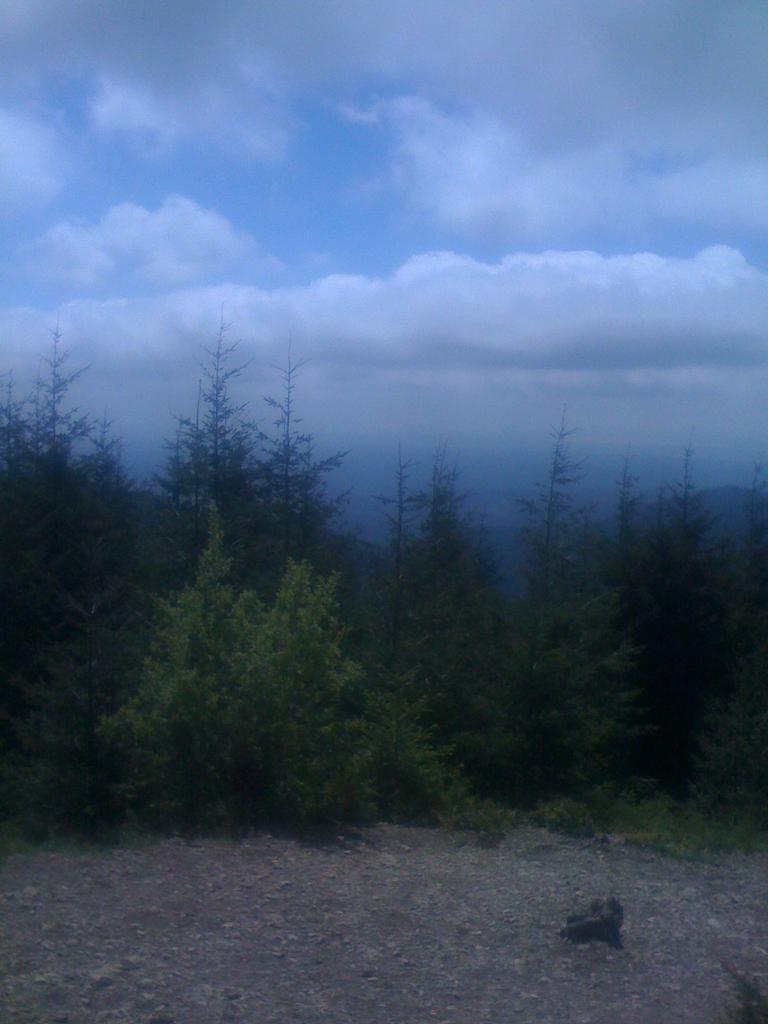Describe this image in one or two sentences. In this image, we can see trees and at the bottom, there is ground and we can see an object. At the top, there are clouds in the sky. 